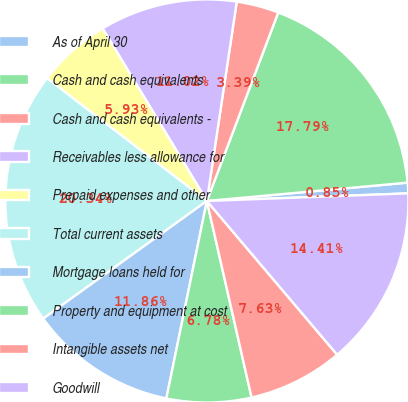Convert chart. <chart><loc_0><loc_0><loc_500><loc_500><pie_chart><fcel>As of April 30<fcel>Cash and cash equivalents<fcel>Cash and cash equivalents -<fcel>Receivables less allowance for<fcel>Prepaid expenses and other<fcel>Total current assets<fcel>Mortgage loans held for<fcel>Property and equipment at cost<fcel>Intangible assets net<fcel>Goodwill<nl><fcel>0.85%<fcel>17.79%<fcel>3.39%<fcel>11.02%<fcel>5.93%<fcel>20.34%<fcel>11.86%<fcel>6.78%<fcel>7.63%<fcel>14.41%<nl></chart> 